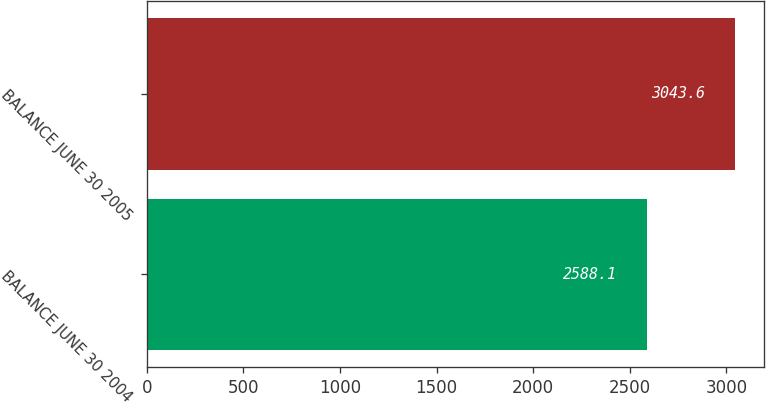<chart> <loc_0><loc_0><loc_500><loc_500><bar_chart><fcel>BALANCE JUNE 30 2004<fcel>BALANCE JUNE 30 2005<nl><fcel>2588.1<fcel>3043.6<nl></chart> 